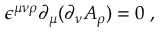Convert formula to latex. <formula><loc_0><loc_0><loc_500><loc_500>\epsilon ^ { \mu \nu \rho } \partial _ { \mu } ( \partial _ { \nu } A _ { \rho } ) = 0 \, ,</formula> 